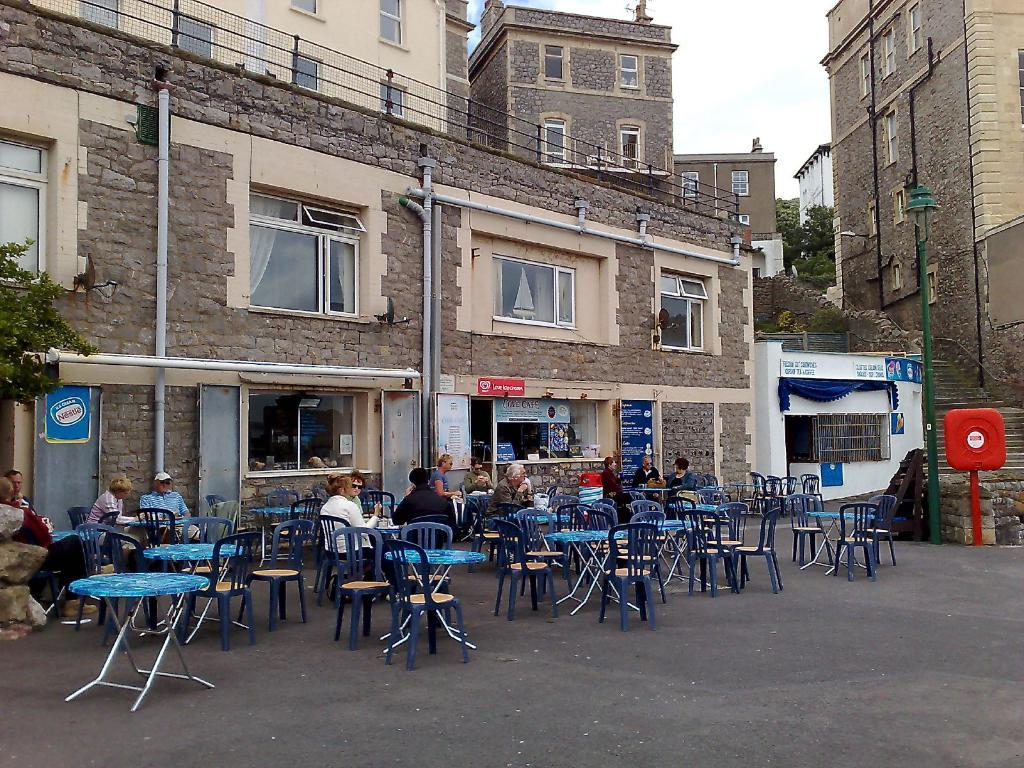Where was the image taken? The image is taken outside. What furniture is visible in the image? There are tables and chairs in the image. What are the people in the image doing? Some people are sitting around the tables. What can be seen in the background of the image? There is a building, a pipe, windows, and a tree in the background of the image. What type of grape is being used as a tablecloth in the image? There is no grape or tablecloth present in the image. What year is depicted on the calendar in the image? There is no calendar present in the image. 